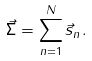Convert formula to latex. <formula><loc_0><loc_0><loc_500><loc_500>\vec { \Sigma } = \sum _ { n = 1 } ^ { N } \vec { s } _ { n } .</formula> 